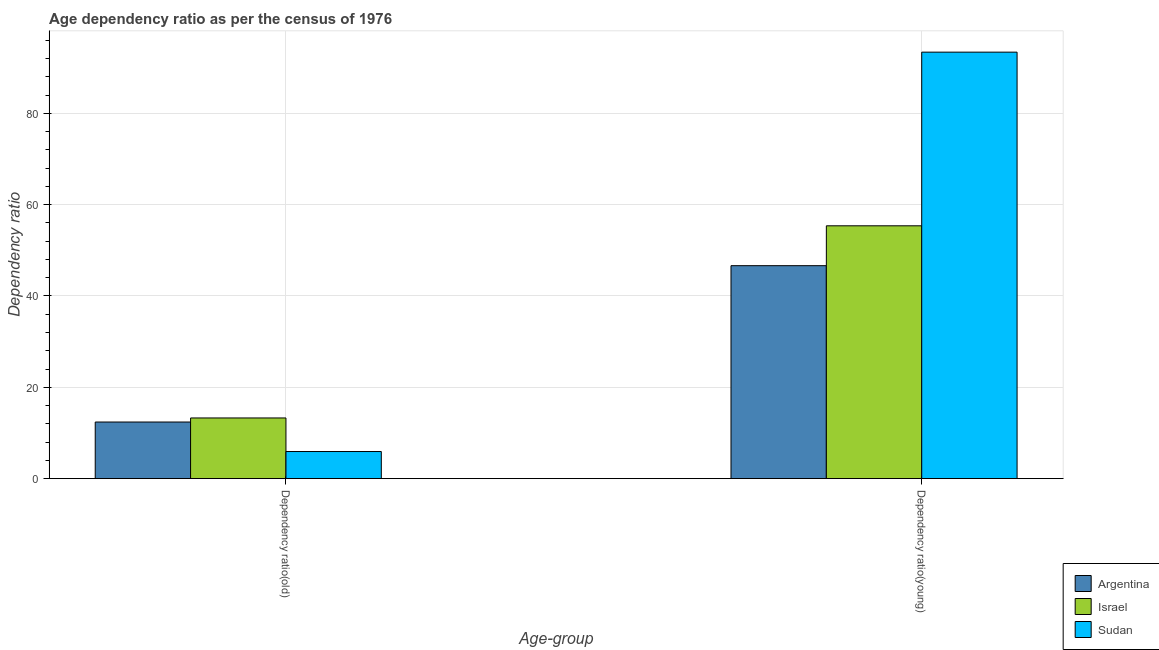How many groups of bars are there?
Your answer should be compact. 2. Are the number of bars per tick equal to the number of legend labels?
Ensure brevity in your answer.  Yes. How many bars are there on the 2nd tick from the left?
Make the answer very short. 3. What is the label of the 2nd group of bars from the left?
Your answer should be compact. Dependency ratio(young). What is the age dependency ratio(old) in Argentina?
Provide a succinct answer. 12.39. Across all countries, what is the maximum age dependency ratio(old)?
Your response must be concise. 13.28. Across all countries, what is the minimum age dependency ratio(old)?
Offer a very short reply. 5.93. In which country was the age dependency ratio(young) maximum?
Offer a terse response. Sudan. In which country was the age dependency ratio(old) minimum?
Ensure brevity in your answer.  Sudan. What is the total age dependency ratio(young) in the graph?
Make the answer very short. 195.4. What is the difference between the age dependency ratio(young) in Argentina and that in Israel?
Offer a very short reply. -8.73. What is the difference between the age dependency ratio(young) in Sudan and the age dependency ratio(old) in Israel?
Give a very brief answer. 80.12. What is the average age dependency ratio(old) per country?
Provide a short and direct response. 10.54. What is the difference between the age dependency ratio(old) and age dependency ratio(young) in Argentina?
Offer a very short reply. -34.24. What is the ratio of the age dependency ratio(young) in Argentina to that in Israel?
Offer a very short reply. 0.84. Is the age dependency ratio(young) in Sudan less than that in Argentina?
Make the answer very short. No. In how many countries, is the age dependency ratio(old) greater than the average age dependency ratio(old) taken over all countries?
Offer a very short reply. 2. What does the 2nd bar from the right in Dependency ratio(old) represents?
Keep it short and to the point. Israel. How many countries are there in the graph?
Offer a very short reply. 3. What is the difference between two consecutive major ticks on the Y-axis?
Your response must be concise. 20. Are the values on the major ticks of Y-axis written in scientific E-notation?
Make the answer very short. No. Does the graph contain any zero values?
Your answer should be very brief. No. Does the graph contain grids?
Ensure brevity in your answer.  Yes. Where does the legend appear in the graph?
Your answer should be very brief. Bottom right. How many legend labels are there?
Keep it short and to the point. 3. What is the title of the graph?
Keep it short and to the point. Age dependency ratio as per the census of 1976. What is the label or title of the X-axis?
Give a very brief answer. Age-group. What is the label or title of the Y-axis?
Your answer should be compact. Dependency ratio. What is the Dependency ratio in Argentina in Dependency ratio(old)?
Your response must be concise. 12.39. What is the Dependency ratio of Israel in Dependency ratio(old)?
Your answer should be very brief. 13.28. What is the Dependency ratio in Sudan in Dependency ratio(old)?
Offer a very short reply. 5.93. What is the Dependency ratio of Argentina in Dependency ratio(young)?
Your answer should be very brief. 46.63. What is the Dependency ratio of Israel in Dependency ratio(young)?
Ensure brevity in your answer.  55.37. What is the Dependency ratio of Sudan in Dependency ratio(young)?
Your answer should be very brief. 93.4. Across all Age-group, what is the maximum Dependency ratio of Argentina?
Your answer should be very brief. 46.63. Across all Age-group, what is the maximum Dependency ratio in Israel?
Your answer should be very brief. 55.37. Across all Age-group, what is the maximum Dependency ratio of Sudan?
Keep it short and to the point. 93.4. Across all Age-group, what is the minimum Dependency ratio in Argentina?
Offer a very short reply. 12.39. Across all Age-group, what is the minimum Dependency ratio of Israel?
Provide a short and direct response. 13.28. Across all Age-group, what is the minimum Dependency ratio of Sudan?
Offer a terse response. 5.93. What is the total Dependency ratio in Argentina in the graph?
Give a very brief answer. 59.03. What is the total Dependency ratio in Israel in the graph?
Your response must be concise. 68.65. What is the total Dependency ratio in Sudan in the graph?
Offer a terse response. 99.33. What is the difference between the Dependency ratio of Argentina in Dependency ratio(old) and that in Dependency ratio(young)?
Offer a terse response. -34.24. What is the difference between the Dependency ratio in Israel in Dependency ratio(old) and that in Dependency ratio(young)?
Keep it short and to the point. -42.08. What is the difference between the Dependency ratio of Sudan in Dependency ratio(old) and that in Dependency ratio(young)?
Your answer should be very brief. -87.46. What is the difference between the Dependency ratio in Argentina in Dependency ratio(old) and the Dependency ratio in Israel in Dependency ratio(young)?
Ensure brevity in your answer.  -42.97. What is the difference between the Dependency ratio of Argentina in Dependency ratio(old) and the Dependency ratio of Sudan in Dependency ratio(young)?
Offer a terse response. -81.01. What is the difference between the Dependency ratio of Israel in Dependency ratio(old) and the Dependency ratio of Sudan in Dependency ratio(young)?
Your answer should be compact. -80.12. What is the average Dependency ratio in Argentina per Age-group?
Your response must be concise. 29.51. What is the average Dependency ratio of Israel per Age-group?
Offer a very short reply. 34.32. What is the average Dependency ratio of Sudan per Age-group?
Your response must be concise. 49.67. What is the difference between the Dependency ratio of Argentina and Dependency ratio of Israel in Dependency ratio(old)?
Your answer should be compact. -0.89. What is the difference between the Dependency ratio of Argentina and Dependency ratio of Sudan in Dependency ratio(old)?
Ensure brevity in your answer.  6.46. What is the difference between the Dependency ratio in Israel and Dependency ratio in Sudan in Dependency ratio(old)?
Your response must be concise. 7.35. What is the difference between the Dependency ratio of Argentina and Dependency ratio of Israel in Dependency ratio(young)?
Ensure brevity in your answer.  -8.73. What is the difference between the Dependency ratio of Argentina and Dependency ratio of Sudan in Dependency ratio(young)?
Your response must be concise. -46.77. What is the difference between the Dependency ratio of Israel and Dependency ratio of Sudan in Dependency ratio(young)?
Offer a terse response. -38.03. What is the ratio of the Dependency ratio in Argentina in Dependency ratio(old) to that in Dependency ratio(young)?
Keep it short and to the point. 0.27. What is the ratio of the Dependency ratio of Israel in Dependency ratio(old) to that in Dependency ratio(young)?
Keep it short and to the point. 0.24. What is the ratio of the Dependency ratio in Sudan in Dependency ratio(old) to that in Dependency ratio(young)?
Offer a terse response. 0.06. What is the difference between the highest and the second highest Dependency ratio of Argentina?
Provide a short and direct response. 34.24. What is the difference between the highest and the second highest Dependency ratio of Israel?
Your response must be concise. 42.08. What is the difference between the highest and the second highest Dependency ratio in Sudan?
Offer a very short reply. 87.46. What is the difference between the highest and the lowest Dependency ratio in Argentina?
Make the answer very short. 34.24. What is the difference between the highest and the lowest Dependency ratio of Israel?
Provide a succinct answer. 42.08. What is the difference between the highest and the lowest Dependency ratio of Sudan?
Your answer should be compact. 87.46. 